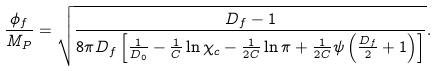Convert formula to latex. <formula><loc_0><loc_0><loc_500><loc_500>\frac { \phi _ { f } } { M _ { P } } = \sqrt { \frac { D _ { f } - 1 } { 8 \pi D _ { f } \left [ \frac { 1 } { D _ { 0 } } - \frac { 1 } { C } \ln \chi _ { c } - \frac { 1 } { 2 C } \ln \pi + \frac { 1 } { 2 C } \psi \left ( \frac { D _ { f } } { 2 } + 1 \right ) \right ] } } .</formula> 